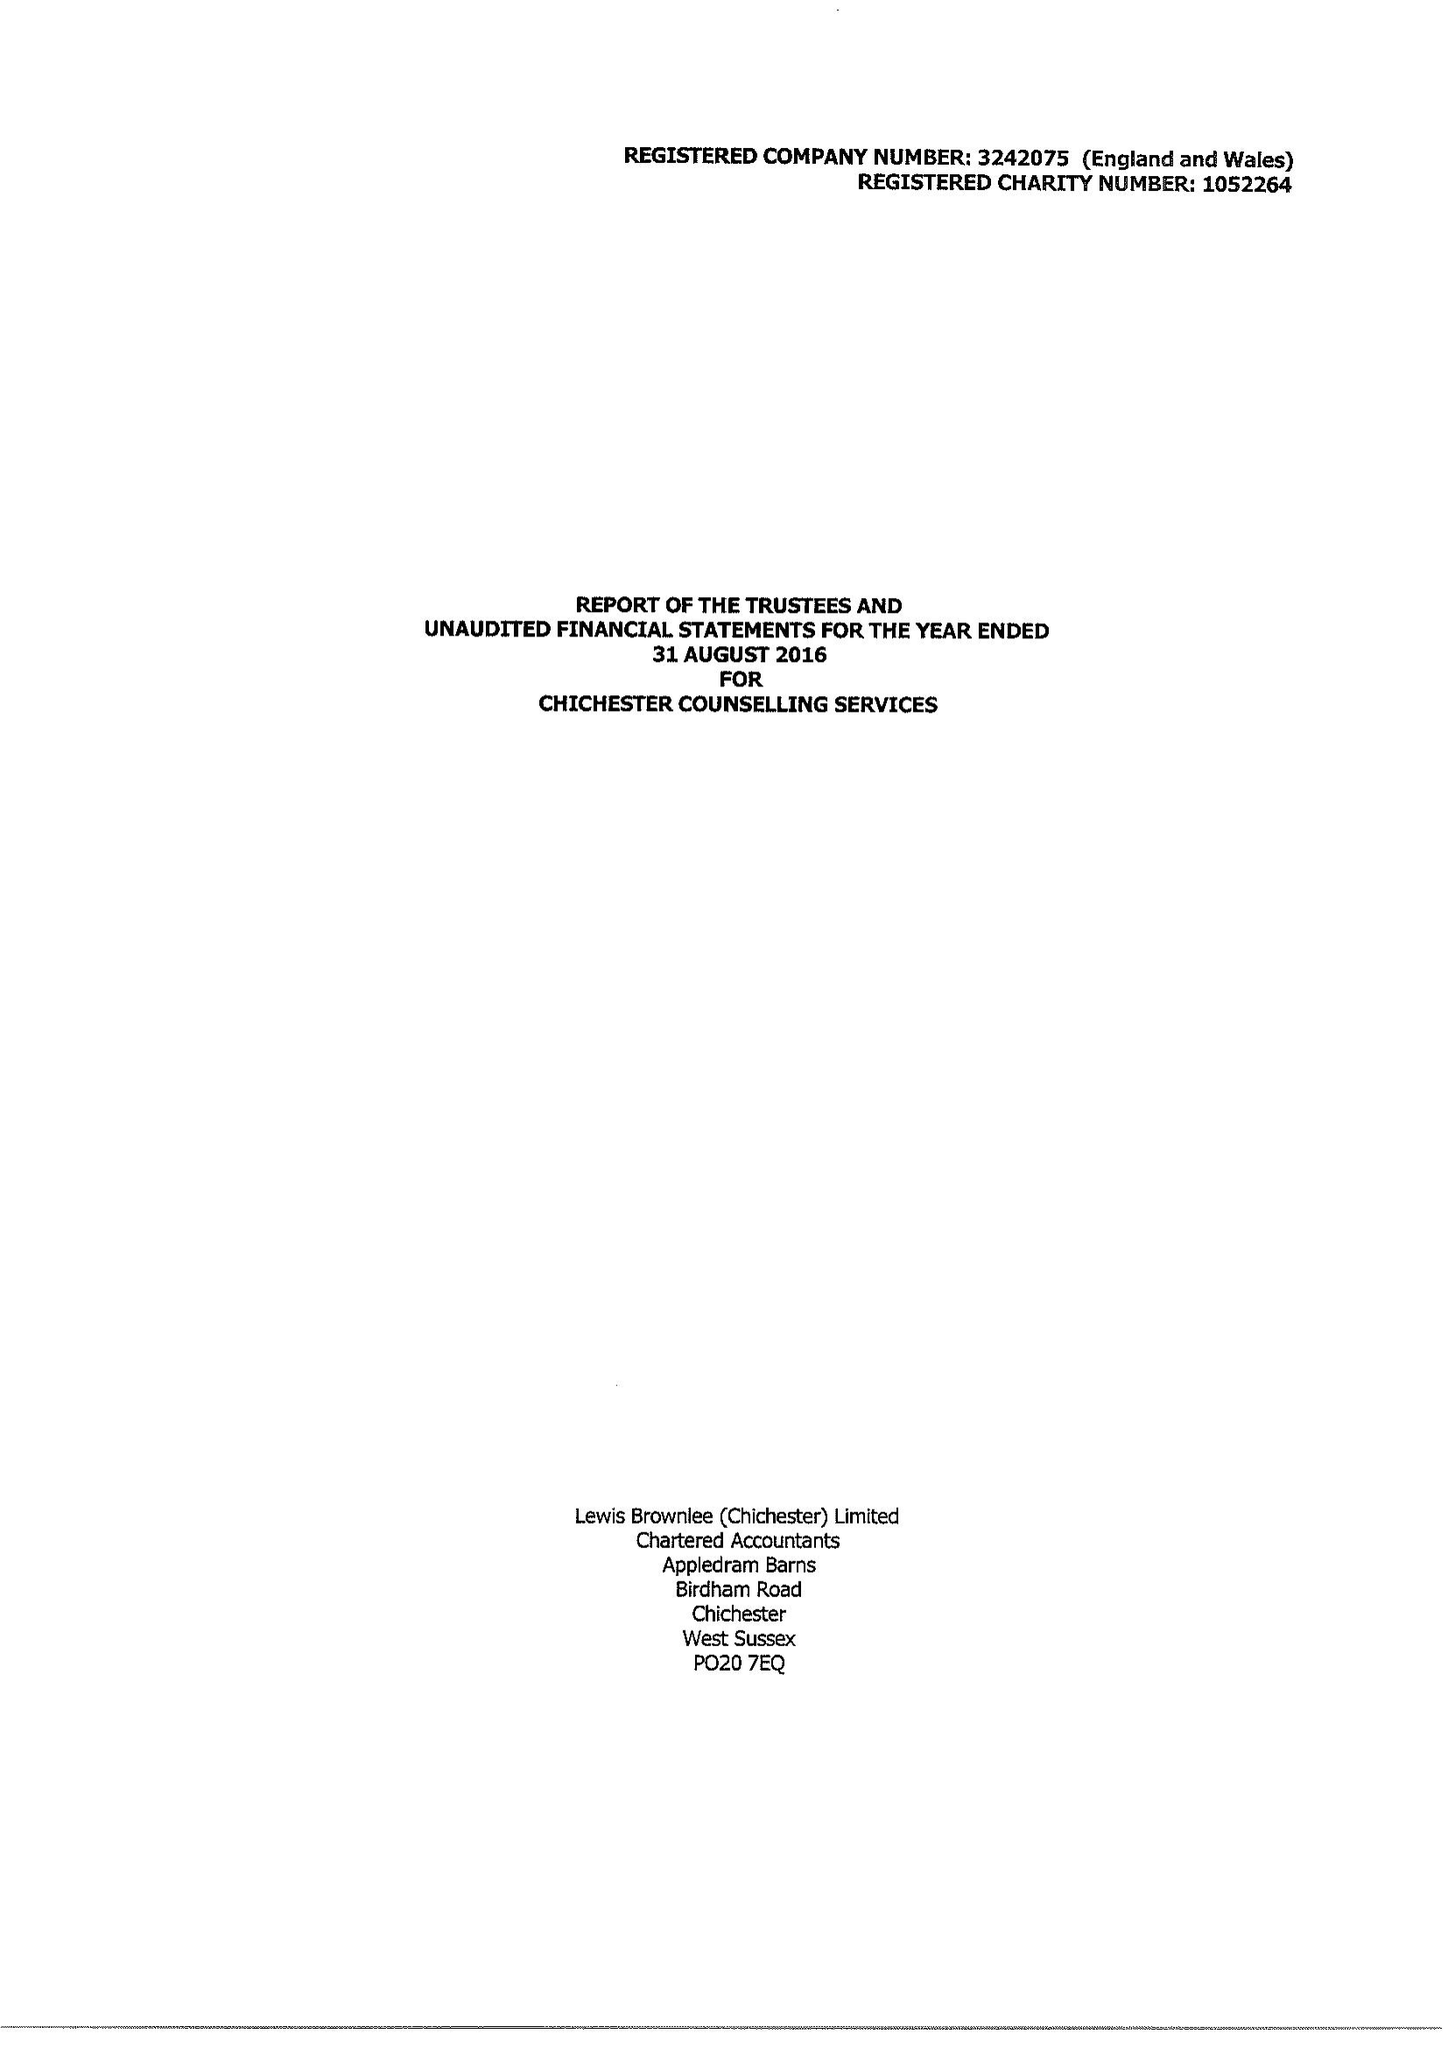What is the value for the address__postcode?
Answer the question using a single word or phrase. None 